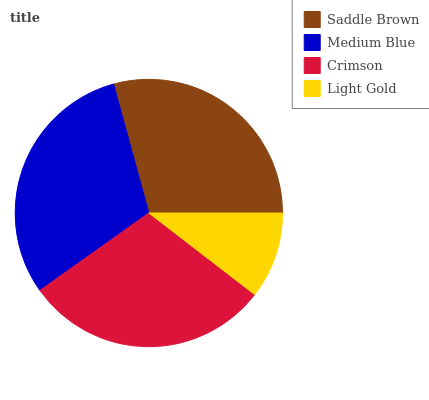Is Light Gold the minimum?
Answer yes or no. Yes. Is Medium Blue the maximum?
Answer yes or no. Yes. Is Crimson the minimum?
Answer yes or no. No. Is Crimson the maximum?
Answer yes or no. No. Is Medium Blue greater than Crimson?
Answer yes or no. Yes. Is Crimson less than Medium Blue?
Answer yes or no. Yes. Is Crimson greater than Medium Blue?
Answer yes or no. No. Is Medium Blue less than Crimson?
Answer yes or no. No. Is Crimson the high median?
Answer yes or no. Yes. Is Saddle Brown the low median?
Answer yes or no. Yes. Is Saddle Brown the high median?
Answer yes or no. No. Is Medium Blue the low median?
Answer yes or no. No. 